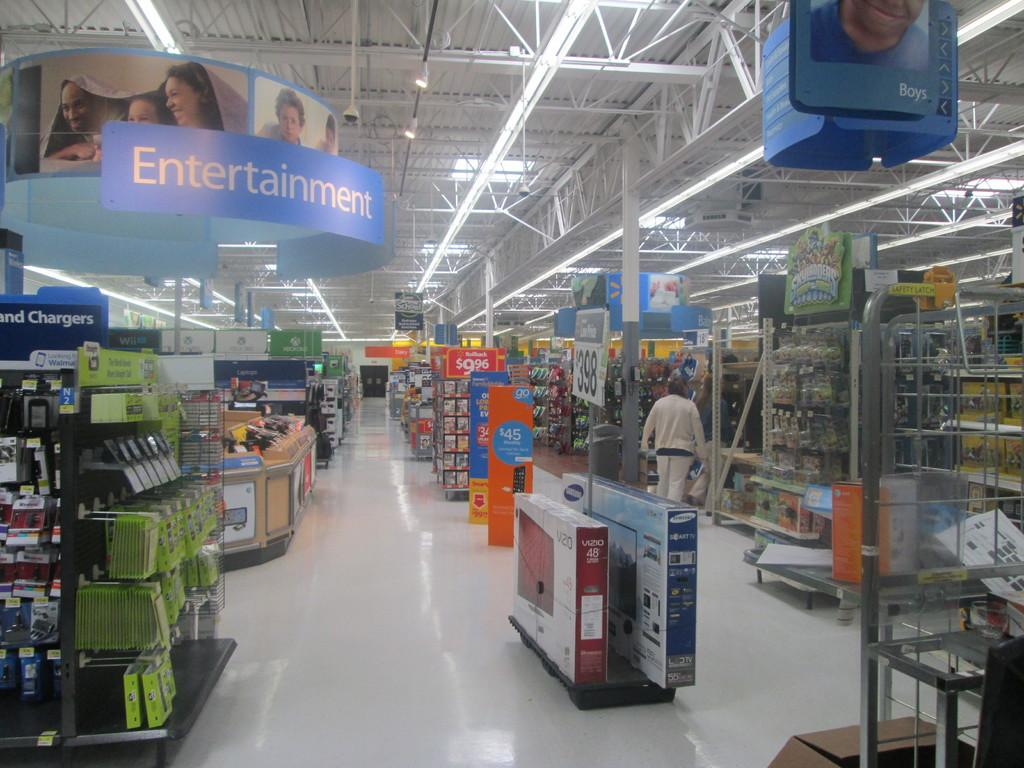<image>
Render a clear and concise summary of the photo. The entertainment section in a local walmart store with a person shopping. 